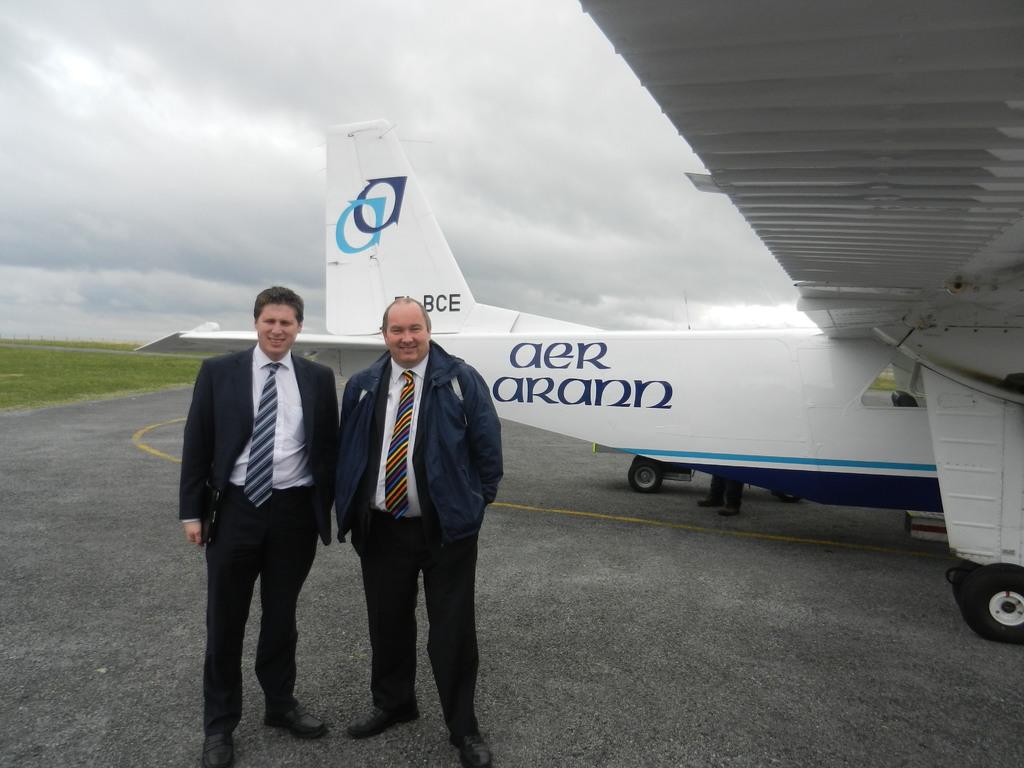What airline is this?
Make the answer very short. Aer arann. What is written above the man's head?
Your answer should be compact. Bce. 